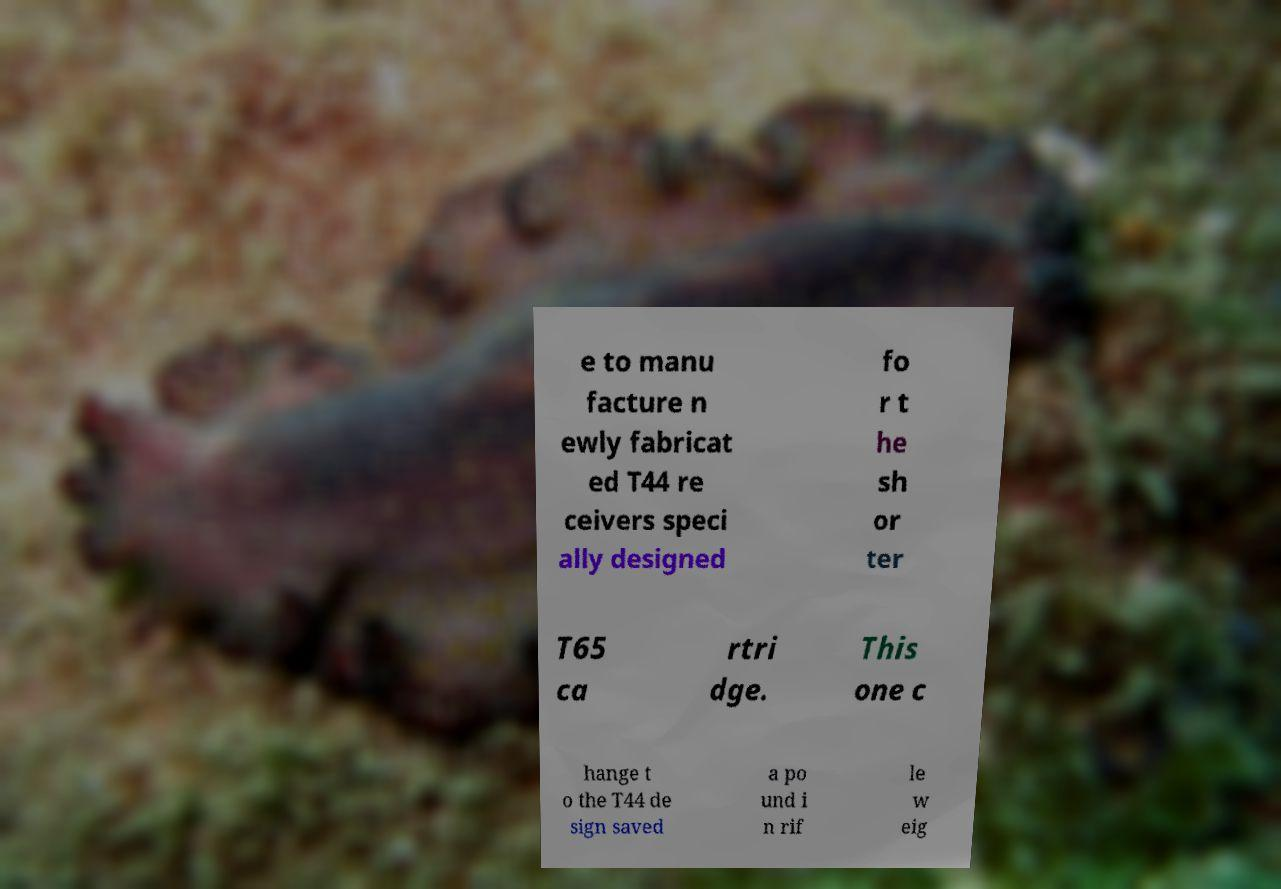For documentation purposes, I need the text within this image transcribed. Could you provide that? e to manu facture n ewly fabricat ed T44 re ceivers speci ally designed fo r t he sh or ter T65 ca rtri dge. This one c hange t o the T44 de sign saved a po und i n rif le w eig 